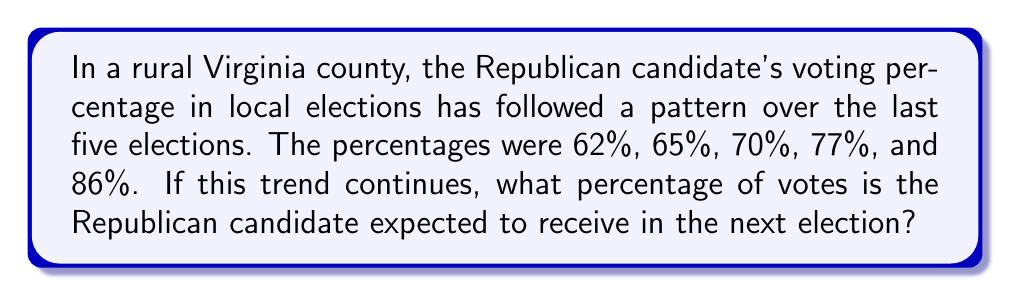Show me your answer to this math problem. Let's analyze the pattern step-by-step:

1) First, let's calculate the differences between consecutive percentages:
   65% - 62% = 3%
   70% - 65% = 5%
   77% - 70% = 7%
   86% - 77% = 9%

2) We can see that the differences are increasing by 2 percentage points each time:
   3%, 5% (3+2), 7% (5+2), 9% (7+2)

3) Following this pattern, the next difference should be:
   9% + 2% = 11%

4) To find the expected percentage for the next election, we add this difference to the last known percentage:
   86% + 11% = 97%

5) We can verify this pattern using the arithmetic sequence formula for the second differences:
   $a_n = a_1 + \frac{n(n-1)}{2}d$
   Where $a_1 = 3$ (first difference) and $d = 2$ (common difference of differences)

   For $n = 5$ (the 5th difference):
   $a_5 = 3 + \frac{5(5-1)}{2}(2) = 3 + 20 = 23$

   Indeed, 86% + 11% = 97%

Therefore, if this trend continues, the Republican candidate is expected to receive 97% of the votes in the next election.
Answer: 97% 